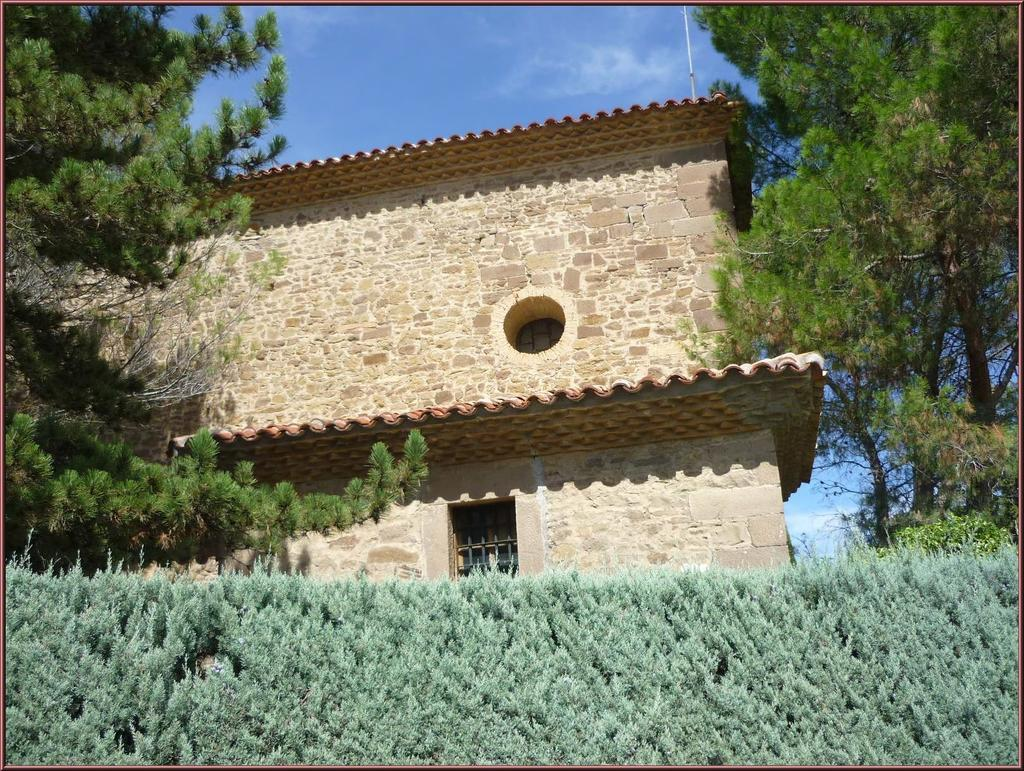What type of structure is in the image? There is a building in the image. What feature can be seen on the building? The building has a window. What natural elements are visible in the image? Trees and the sky are visible in the image. What is present at the bottom of the image? Plants are present at the bottom of the image. What can be seen in the sky? There are clouds in the sky. How is the image framed? The image has borders. How many frogs are sitting on the yam in the basin in the image? There are no frogs, yams, or basins present in the image. 